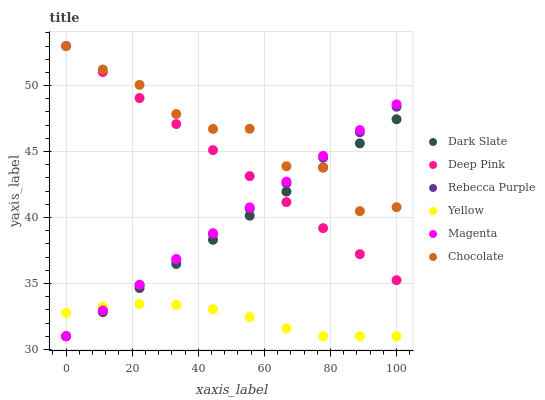Does Yellow have the minimum area under the curve?
Answer yes or no. Yes. Does Chocolate have the maximum area under the curve?
Answer yes or no. Yes. Does Chocolate have the minimum area under the curve?
Answer yes or no. No. Does Yellow have the maximum area under the curve?
Answer yes or no. No. Is Rebecca Purple the smoothest?
Answer yes or no. Yes. Is Chocolate the roughest?
Answer yes or no. Yes. Is Yellow the smoothest?
Answer yes or no. No. Is Yellow the roughest?
Answer yes or no. No. Does Yellow have the lowest value?
Answer yes or no. Yes. Does Chocolate have the lowest value?
Answer yes or no. No. Does Chocolate have the highest value?
Answer yes or no. Yes. Does Yellow have the highest value?
Answer yes or no. No. Is Yellow less than Chocolate?
Answer yes or no. Yes. Is Deep Pink greater than Yellow?
Answer yes or no. Yes. Does Deep Pink intersect Chocolate?
Answer yes or no. Yes. Is Deep Pink less than Chocolate?
Answer yes or no. No. Is Deep Pink greater than Chocolate?
Answer yes or no. No. Does Yellow intersect Chocolate?
Answer yes or no. No. 